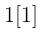Convert formula to latex. <formula><loc_0><loc_0><loc_500><loc_500>\begin{smallmatrix} 1 [ 1 ] \end{smallmatrix}</formula> 